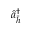Convert formula to latex. <formula><loc_0><loc_0><loc_500><loc_500>\hat { a } _ { \bar { h } } ^ { \dagger }</formula> 